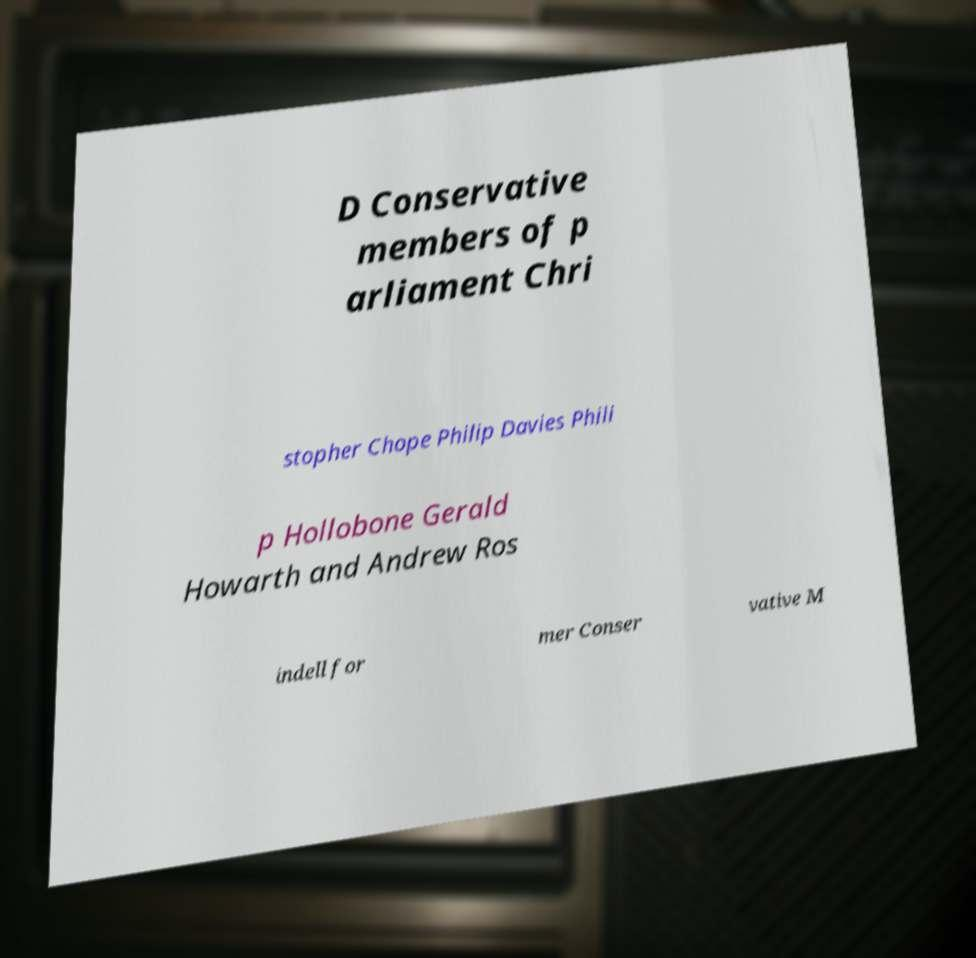Can you accurately transcribe the text from the provided image for me? D Conservative members of p arliament Chri stopher Chope Philip Davies Phili p Hollobone Gerald Howarth and Andrew Ros indell for mer Conser vative M 